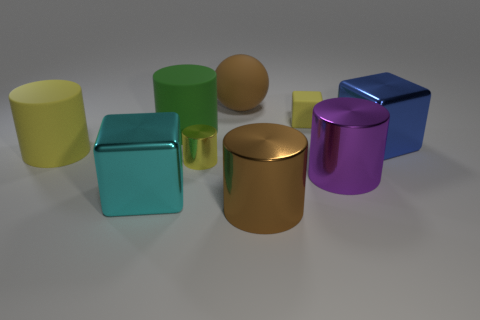Subtract all metallic cylinders. How many cylinders are left? 2 Add 1 large cyan blocks. How many objects exist? 10 Subtract all cyan cubes. How many cubes are left? 2 Subtract all balls. How many objects are left? 8 Add 5 blue objects. How many blue objects are left? 6 Add 5 small gray metallic things. How many small gray metallic things exist? 5 Subtract 0 yellow spheres. How many objects are left? 9 Subtract 1 cylinders. How many cylinders are left? 4 Subtract all cyan cylinders. Subtract all blue spheres. How many cylinders are left? 5 Subtract all green spheres. How many cyan blocks are left? 1 